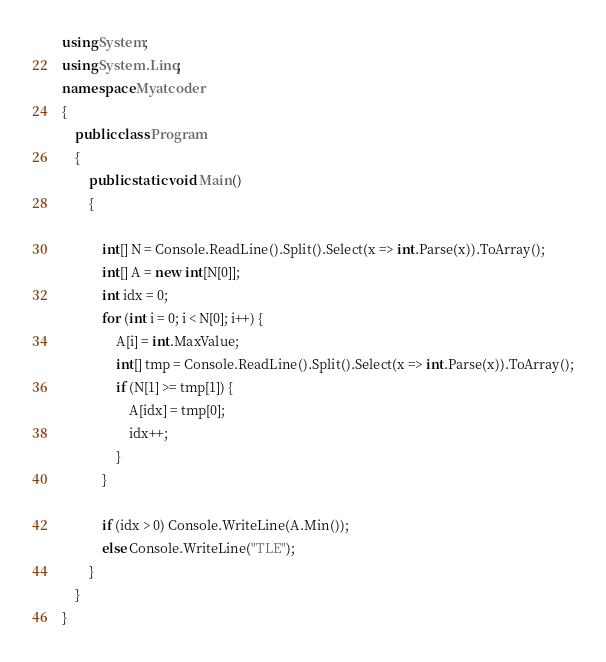<code> <loc_0><loc_0><loc_500><loc_500><_C#_>using System;
using System.Linq;
namespace Myatcoder
{
    public class Program
    {
        public static void Main()
        {

            int[] N = Console.ReadLine().Split().Select(x => int.Parse(x)).ToArray();
            int[] A = new int[N[0]];
            int idx = 0;
            for (int i = 0; i < N[0]; i++) {
                A[i] = int.MaxValue;
                int[] tmp = Console.ReadLine().Split().Select(x => int.Parse(x)).ToArray();
                if (N[1] >= tmp[1]) {
                    A[idx] = tmp[0];
                    idx++;
                }
            }

            if (idx > 0) Console.WriteLine(A.Min());
            else Console.WriteLine("TLE");
        }
    }
}</code> 